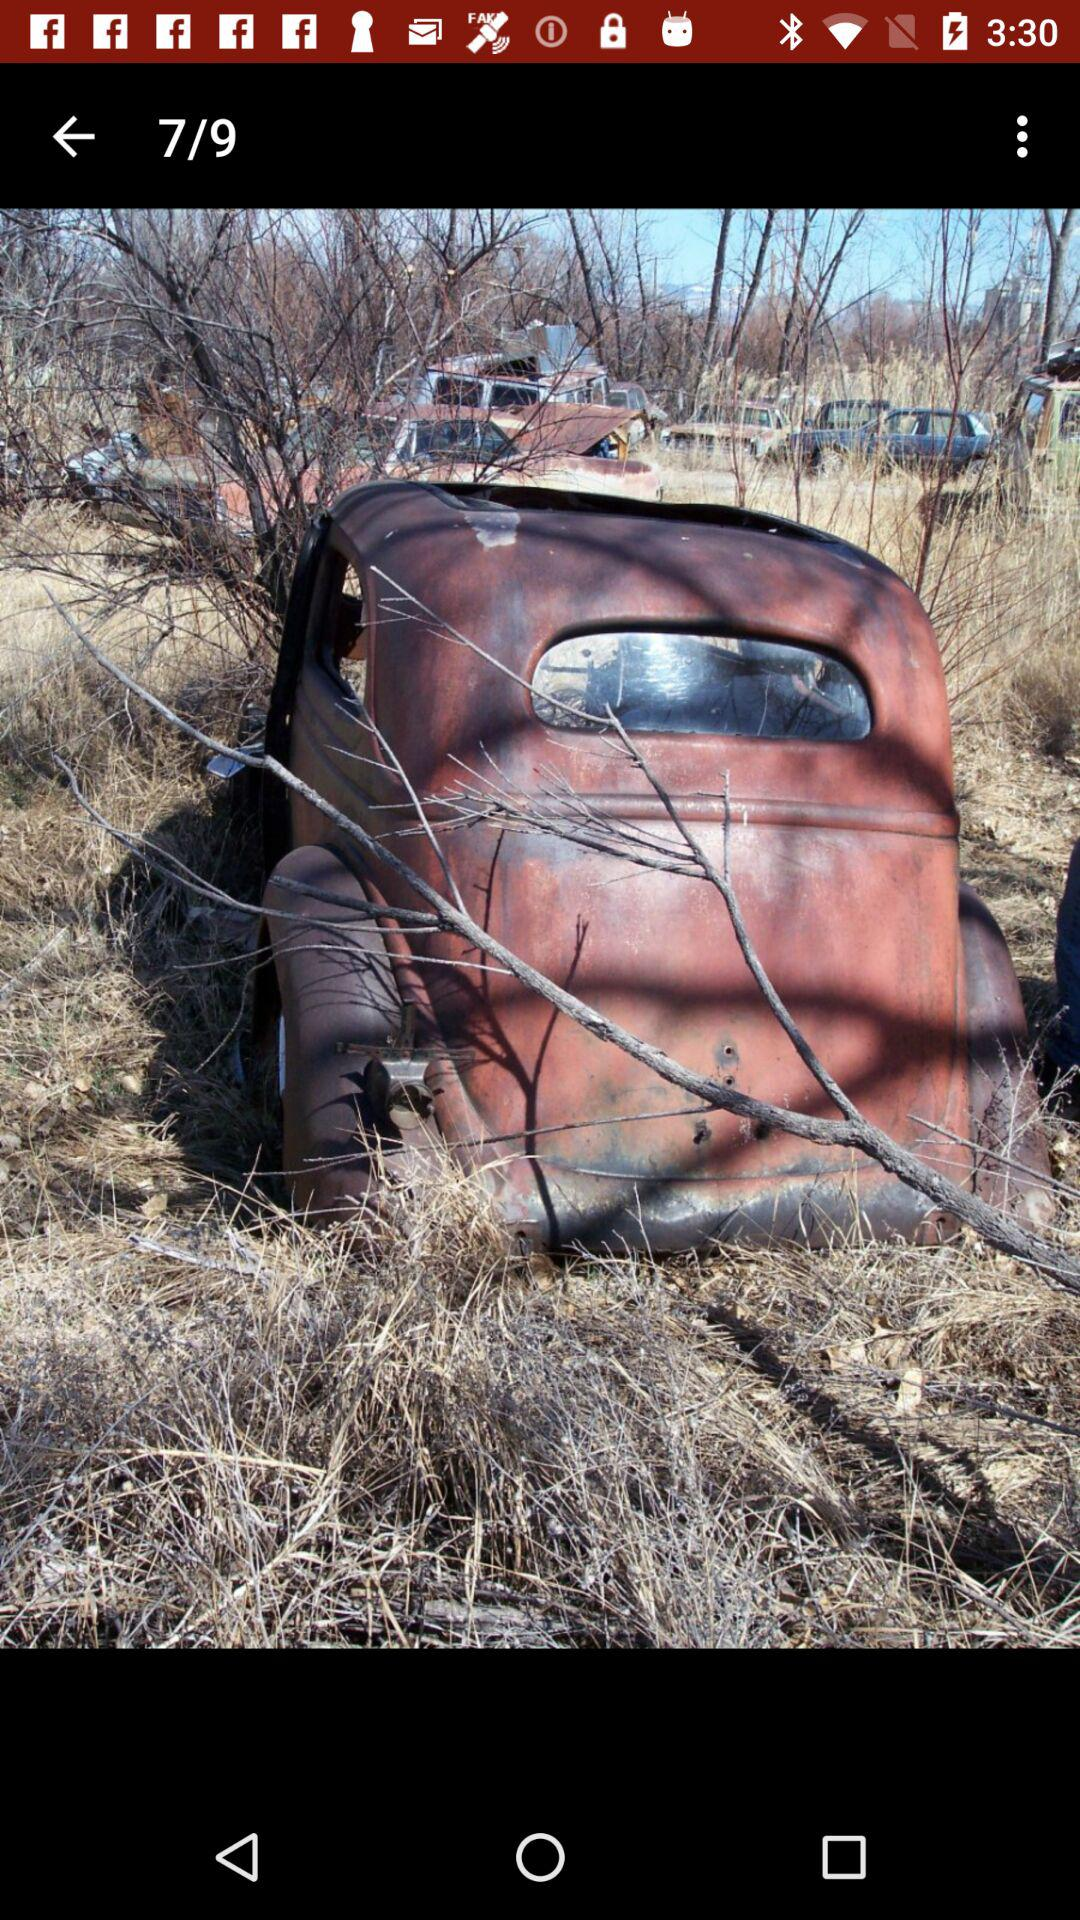How many hours ago was this image uploaded?
When the provided information is insufficient, respond with <no answer>. <no answer> 